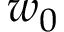<formula> <loc_0><loc_0><loc_500><loc_500>w _ { 0 }</formula> 